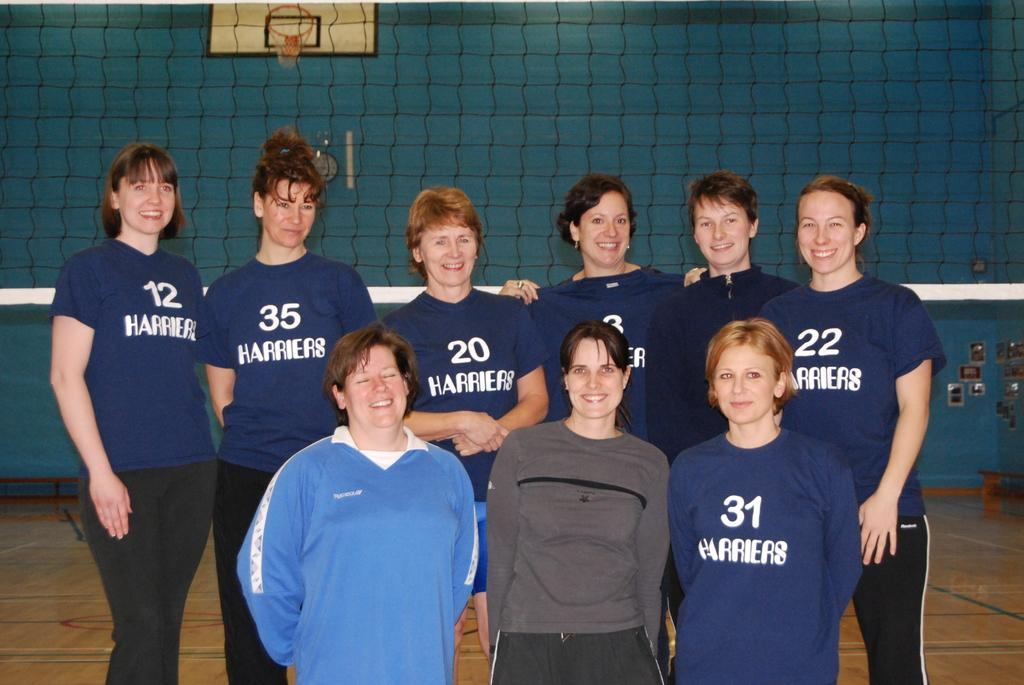<image>
Offer a succinct explanation of the picture presented. Some sports players with numbers on blue shirts, the number 31 is visible. 